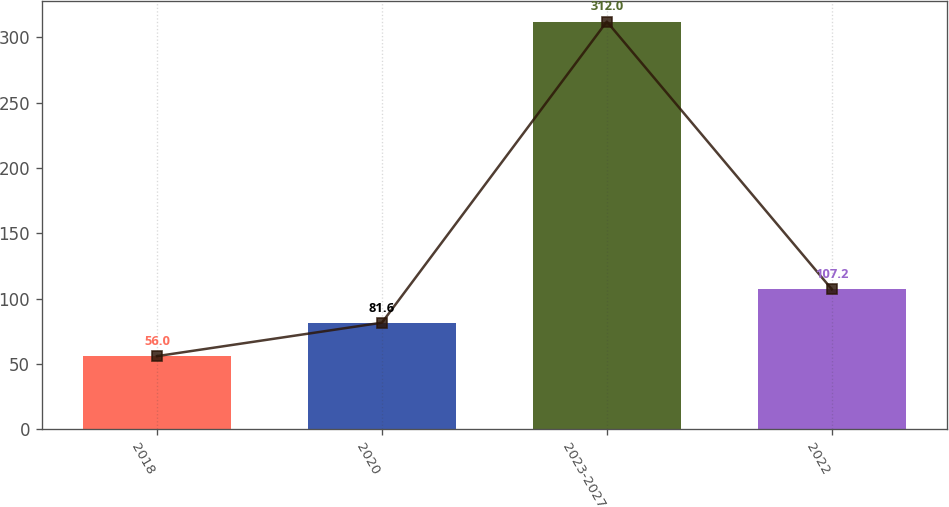Convert chart to OTSL. <chart><loc_0><loc_0><loc_500><loc_500><bar_chart><fcel>2018<fcel>2020<fcel>2023-2027<fcel>2022<nl><fcel>56<fcel>81.6<fcel>312<fcel>107.2<nl></chart> 